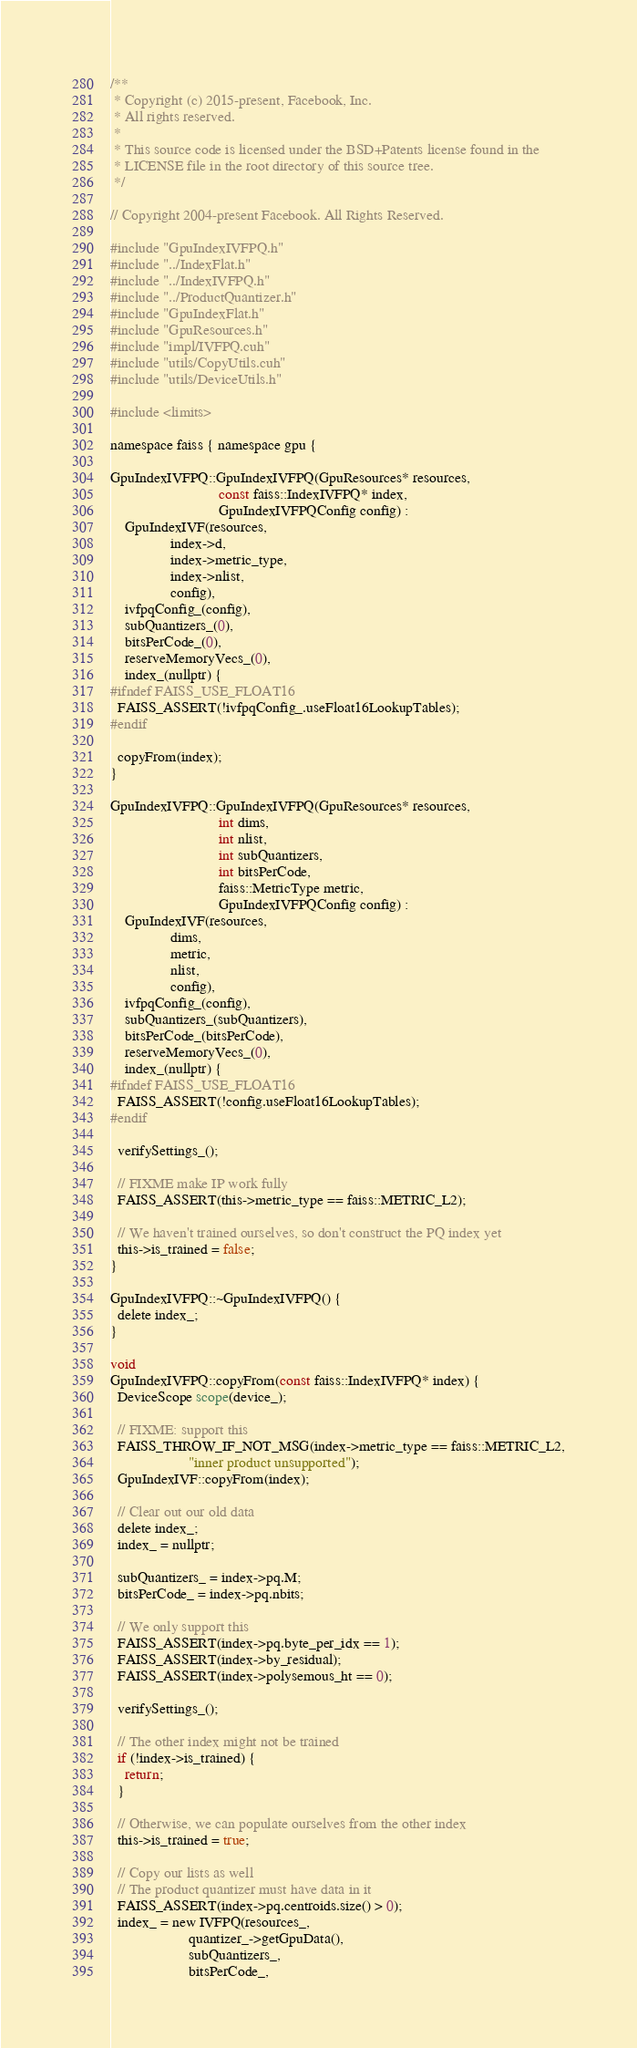Convert code to text. <code><loc_0><loc_0><loc_500><loc_500><_Cuda_>/**
 * Copyright (c) 2015-present, Facebook, Inc.
 * All rights reserved.
 *
 * This source code is licensed under the BSD+Patents license found in the
 * LICENSE file in the root directory of this source tree.
 */

// Copyright 2004-present Facebook. All Rights Reserved.

#include "GpuIndexIVFPQ.h"
#include "../IndexFlat.h"
#include "../IndexIVFPQ.h"
#include "../ProductQuantizer.h"
#include "GpuIndexFlat.h"
#include "GpuResources.h"
#include "impl/IVFPQ.cuh"
#include "utils/CopyUtils.cuh"
#include "utils/DeviceUtils.h"

#include <limits>

namespace faiss { namespace gpu {

GpuIndexIVFPQ::GpuIndexIVFPQ(GpuResources* resources,
                             const faiss::IndexIVFPQ* index,
                             GpuIndexIVFPQConfig config) :
    GpuIndexIVF(resources,
                index->d,
                index->metric_type,
                index->nlist,
                config),
    ivfpqConfig_(config),
    subQuantizers_(0),
    bitsPerCode_(0),
    reserveMemoryVecs_(0),
    index_(nullptr) {
#ifndef FAISS_USE_FLOAT16
  FAISS_ASSERT(!ivfpqConfig_.useFloat16LookupTables);
#endif

  copyFrom(index);
}

GpuIndexIVFPQ::GpuIndexIVFPQ(GpuResources* resources,
                             int dims,
                             int nlist,
                             int subQuantizers,
                             int bitsPerCode,
                             faiss::MetricType metric,
                             GpuIndexIVFPQConfig config) :
    GpuIndexIVF(resources,
                dims,
                metric,
                nlist,
                config),
    ivfpqConfig_(config),
    subQuantizers_(subQuantizers),
    bitsPerCode_(bitsPerCode),
    reserveMemoryVecs_(0),
    index_(nullptr) {
#ifndef FAISS_USE_FLOAT16
  FAISS_ASSERT(!config.useFloat16LookupTables);
#endif

  verifySettings_();

  // FIXME make IP work fully
  FAISS_ASSERT(this->metric_type == faiss::METRIC_L2);

  // We haven't trained ourselves, so don't construct the PQ index yet
  this->is_trained = false;
}

GpuIndexIVFPQ::~GpuIndexIVFPQ() {
  delete index_;
}

void
GpuIndexIVFPQ::copyFrom(const faiss::IndexIVFPQ* index) {
  DeviceScope scope(device_);

  // FIXME: support this
  FAISS_THROW_IF_NOT_MSG(index->metric_type == faiss::METRIC_L2,
                     "inner product unsupported");
  GpuIndexIVF::copyFrom(index);

  // Clear out our old data
  delete index_;
  index_ = nullptr;

  subQuantizers_ = index->pq.M;
  bitsPerCode_ = index->pq.nbits;

  // We only support this
  FAISS_ASSERT(index->pq.byte_per_idx == 1);
  FAISS_ASSERT(index->by_residual);
  FAISS_ASSERT(index->polysemous_ht == 0);

  verifySettings_();

  // The other index might not be trained
  if (!index->is_trained) {
    return;
  }

  // Otherwise, we can populate ourselves from the other index
  this->is_trained = true;

  // Copy our lists as well
  // The product quantizer must have data in it
  FAISS_ASSERT(index->pq.centroids.size() > 0);
  index_ = new IVFPQ(resources_,
                     quantizer_->getGpuData(),
                     subQuantizers_,
                     bitsPerCode_,</code> 